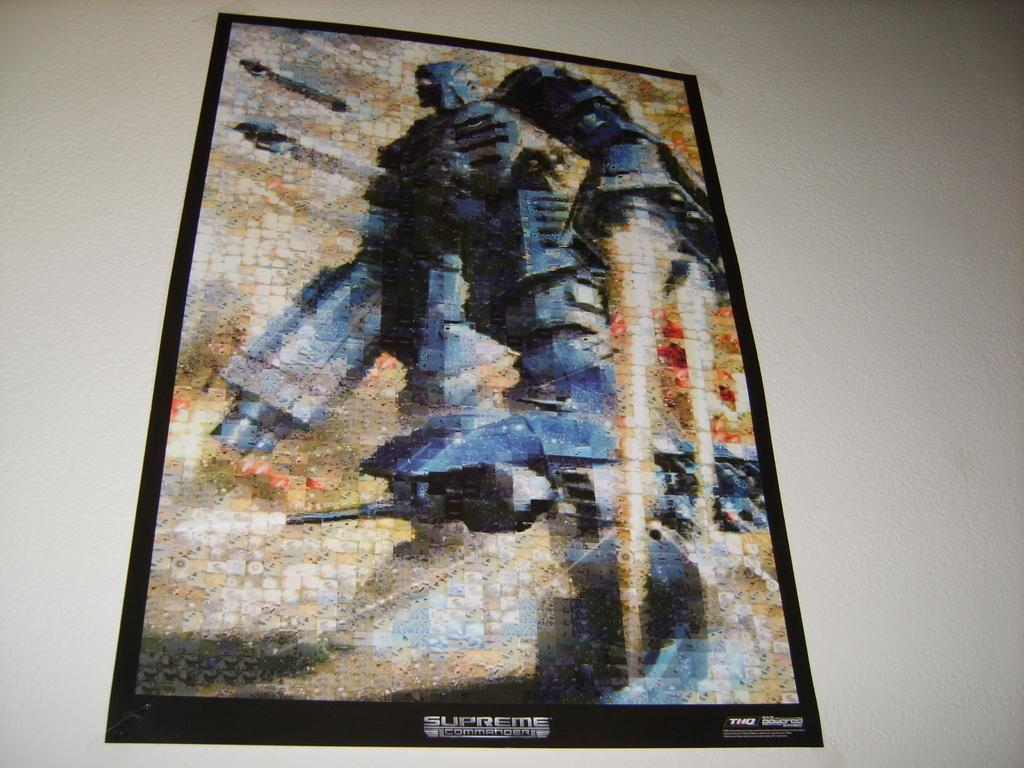What is on the wall in the image? There is a poster on the wall in the image. What is depicted on the poster? The poster features a robot. How many men are holding the letter in the image? There are no men or letters present in the image; it only features a poster with a robot. 